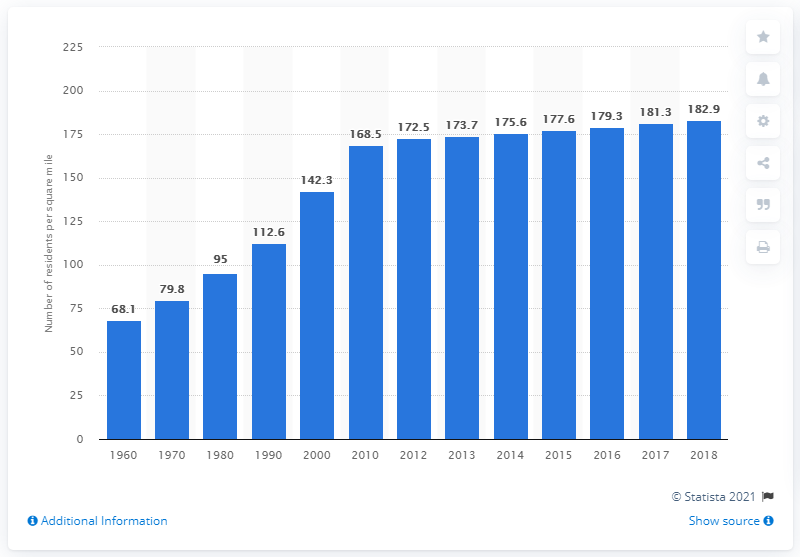Indicate a few pertinent items in this graphic. In 2018, the population density of Georgia was 182.9 people per square kilometer. 